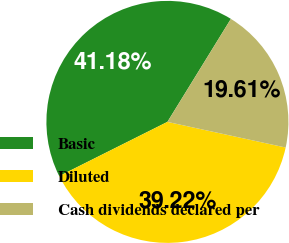<chart> <loc_0><loc_0><loc_500><loc_500><pie_chart><fcel>Basic<fcel>Diluted<fcel>Cash dividends declared per<nl><fcel>41.18%<fcel>39.22%<fcel>19.61%<nl></chart> 